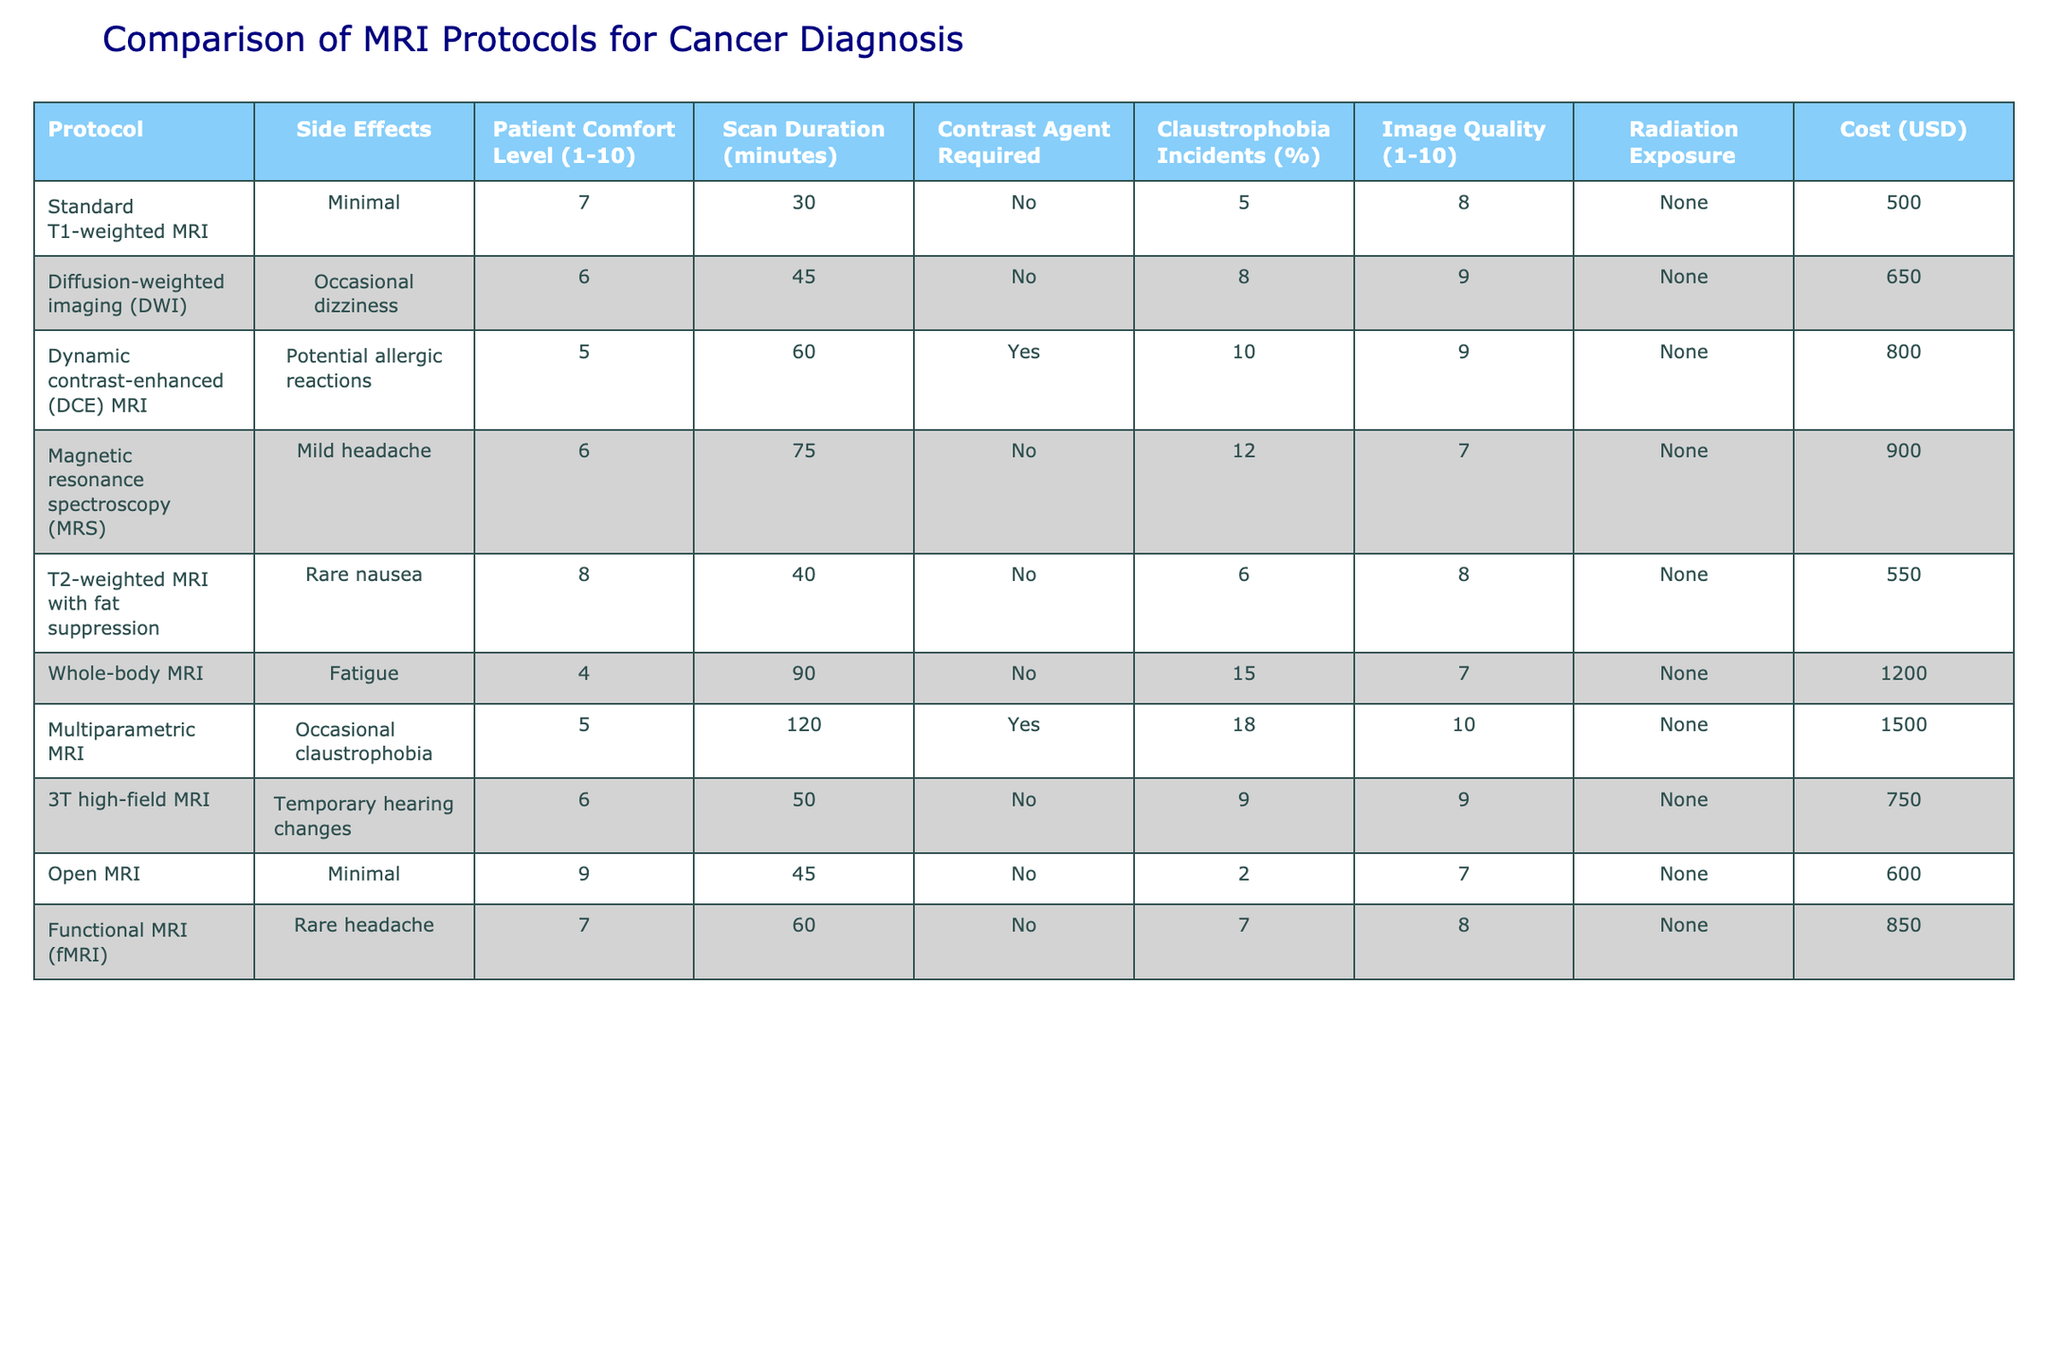What is the patient comfort level for Open MRI? The table indicates that the patient comfort level for Open MRI is 9, which is relatively high compared to other protocols.
Answer: 9 Which MRI protocol requires a contrast agent? From the table, the Dynamic contrast-enhanced (DCE) MRI is the only protocol listed that requires a contrast agent, as indicated in the corresponding column.
Answer: Yes What is the cost difference between Whole-body MRI and Multiparametric MRI? The cost of Whole-body MRI is 1200 USD and the cost of Multiparametric MRI is 1500 USD. The difference is 1500 - 1200 = 300 USD.
Answer: 300 USD What is the average patient comfort level for protocols that have a "Minimal" side effect? The protocols with a "Minimal" side effect are Standard T1-weighted MRI and Open MRI. Their comfort levels are 7 and 9, respectively. The average is (7 + 9) / 2 = 8.
Answer: 8 Is there any protocol with zero claustrophobia incidents? By reviewing the table, I can see that Open MRI has the lowest claustrophobia incidents at 2%, indicating it experience less than others, while Standard T1-weighted MRI has 5% and others higher. Therefore, the claim is false regarding a protocol having zero claustrophobia incidents.
Answer: No Which MRI protocol has the highest image quality rating? The Multiparametric MRI has the highest image quality rating of 10, as indicated in the image quality column of the table.
Answer: 10 What is the total scan duration for Diffusion-weighted imaging (DWI) and Whole-body MRI? Looking at the scan durations, Diffusion-weighted imaging (DWI) is 45 minutes and Whole-body MRI is 90 minutes. Their total is 45 + 90 = 135 minutes.
Answer: 135 minutes How many protocols report potential reactions as side effects? The table lists three protocols with potential reactions as side effects: Dynamic contrast-enhanced (DCE) MRI (potential allergic reactions), Diffusion-weighted imaging (DWI) (occasional dizziness), and Magnetic resonance spectroscopy (MRS) (mild headache). Therefore, there are a total of three protocols.
Answer: 3 